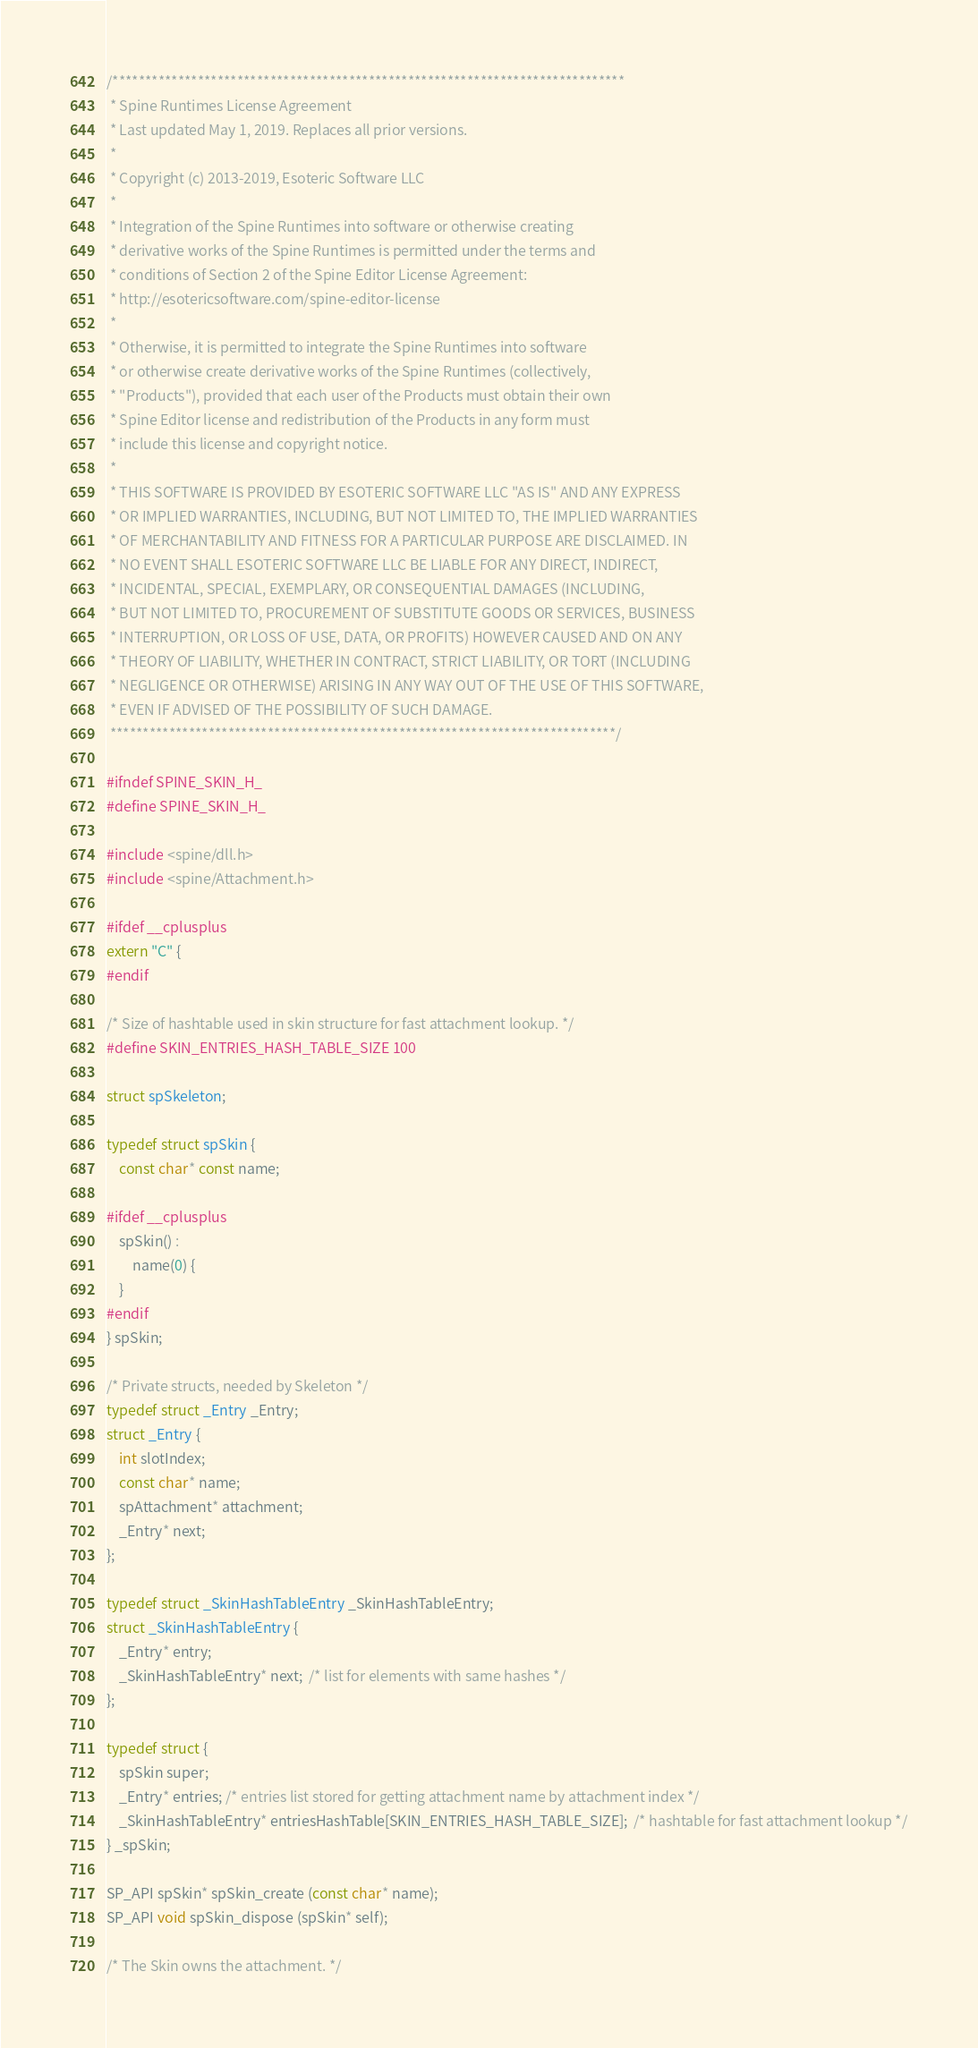<code> <loc_0><loc_0><loc_500><loc_500><_C_>/******************************************************************************
 * Spine Runtimes License Agreement
 * Last updated May 1, 2019. Replaces all prior versions.
 *
 * Copyright (c) 2013-2019, Esoteric Software LLC
 *
 * Integration of the Spine Runtimes into software or otherwise creating
 * derivative works of the Spine Runtimes is permitted under the terms and
 * conditions of Section 2 of the Spine Editor License Agreement:
 * http://esotericsoftware.com/spine-editor-license
 *
 * Otherwise, it is permitted to integrate the Spine Runtimes into software
 * or otherwise create derivative works of the Spine Runtimes (collectively,
 * "Products"), provided that each user of the Products must obtain their own
 * Spine Editor license and redistribution of the Products in any form must
 * include this license and copyright notice.
 *
 * THIS SOFTWARE IS PROVIDED BY ESOTERIC SOFTWARE LLC "AS IS" AND ANY EXPRESS
 * OR IMPLIED WARRANTIES, INCLUDING, BUT NOT LIMITED TO, THE IMPLIED WARRANTIES
 * OF MERCHANTABILITY AND FITNESS FOR A PARTICULAR PURPOSE ARE DISCLAIMED. IN
 * NO EVENT SHALL ESOTERIC SOFTWARE LLC BE LIABLE FOR ANY DIRECT, INDIRECT,
 * INCIDENTAL, SPECIAL, EXEMPLARY, OR CONSEQUENTIAL DAMAGES (INCLUDING,
 * BUT NOT LIMITED TO, PROCUREMENT OF SUBSTITUTE GOODS OR SERVICES, BUSINESS
 * INTERRUPTION, OR LOSS OF USE, DATA, OR PROFITS) HOWEVER CAUSED AND ON ANY
 * THEORY OF LIABILITY, WHETHER IN CONTRACT, STRICT LIABILITY, OR TORT (INCLUDING
 * NEGLIGENCE OR OTHERWISE) ARISING IN ANY WAY OUT OF THE USE OF THIS SOFTWARE,
 * EVEN IF ADVISED OF THE POSSIBILITY OF SUCH DAMAGE.
 *****************************************************************************/

#ifndef SPINE_SKIN_H_
#define SPINE_SKIN_H_

#include <spine/dll.h>
#include <spine/Attachment.h>

#ifdef __cplusplus
extern "C" {
#endif

/* Size of hashtable used in skin structure for fast attachment lookup. */
#define SKIN_ENTRIES_HASH_TABLE_SIZE 100

struct spSkeleton;

typedef struct spSkin {
	const char* const name;

#ifdef __cplusplus
	spSkin() :
		name(0) {
	}
#endif
} spSkin;

/* Private structs, needed by Skeleton */
typedef struct _Entry _Entry;
struct _Entry {
	int slotIndex;
	const char* name;
	spAttachment* attachment;
	_Entry* next;
};

typedef struct _SkinHashTableEntry _SkinHashTableEntry;
struct _SkinHashTableEntry {
	_Entry* entry;
	_SkinHashTableEntry* next;  /* list for elements with same hashes */
};

typedef struct {
	spSkin super;
	_Entry* entries; /* entries list stored for getting attachment name by attachment index */
	_SkinHashTableEntry* entriesHashTable[SKIN_ENTRIES_HASH_TABLE_SIZE];  /* hashtable for fast attachment lookup */
} _spSkin;

SP_API spSkin* spSkin_create (const char* name);
SP_API void spSkin_dispose (spSkin* self);

/* The Skin owns the attachment. */</code> 